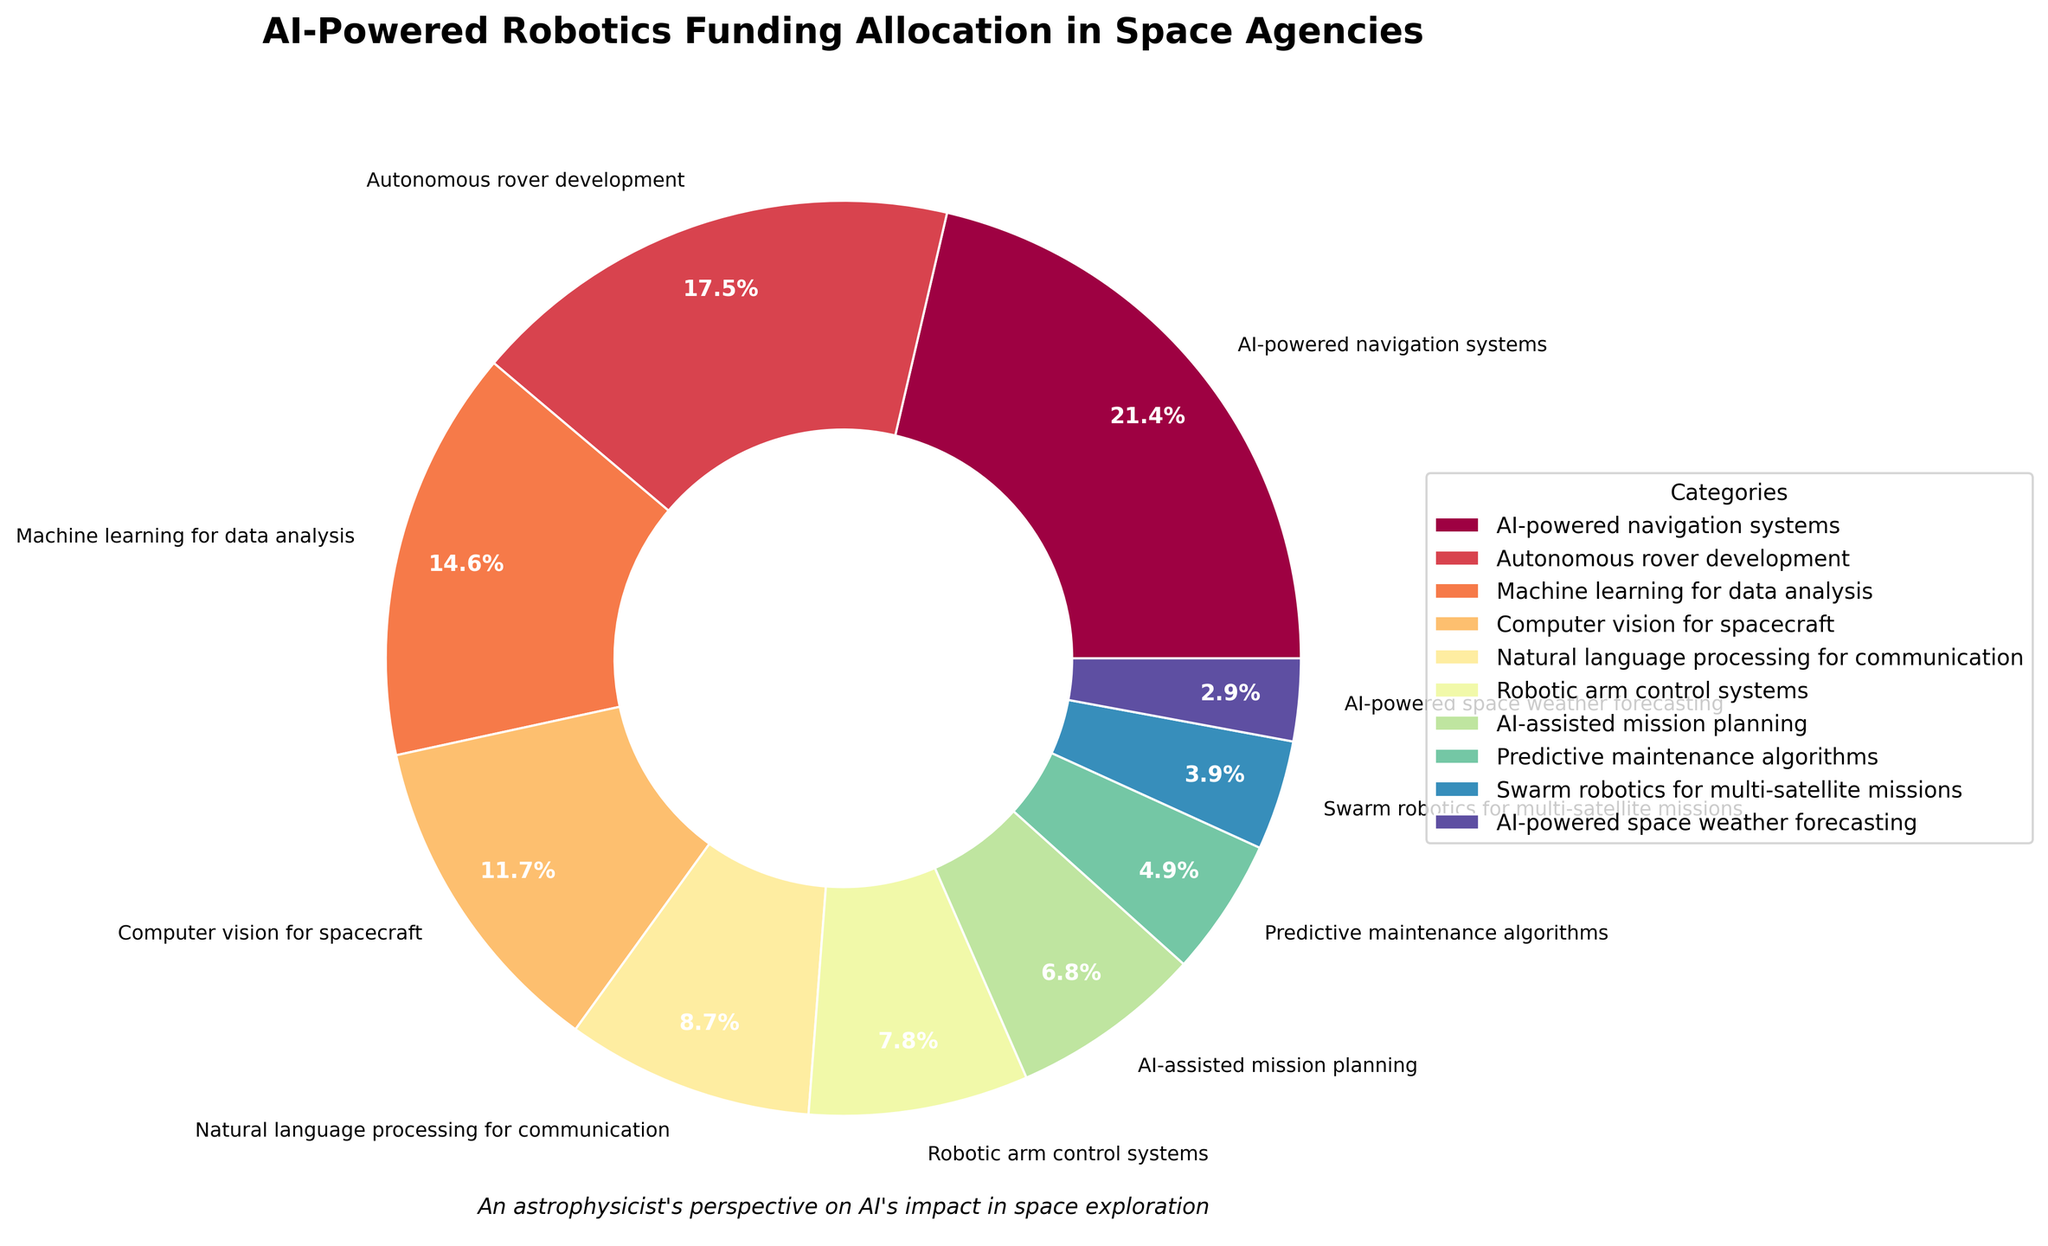How much funding is allocated to AI-powered navigation systems and autonomous rover development combined? To find the combined funding allocation for AI-powered navigation systems and autonomous rover development, add their percentages: 22% (AI-powered navigation systems) + 18% (autonomous rover development) = 40%.
Answer: 40% Which category gets more funding, machine learning for data analysis or computer vision for spacecraft? Compare the percentages: machine learning for data analysis (15%) and computer vision for spacecraft (12%). Since 15% is greater than 12%, machine learning for data analysis gets more funding.
Answer: Machine learning for data analysis What is the total funding allocated to categories related to data analysis and communication, specifically machine learning for data analysis and natural language processing for communication? Add the respective percentages: 15% (machine learning for data analysis) + 9% (natural language processing for communication) = 24%.
Answer: 24% Is the funding for AI-powered navigation systems greater than the combined funding for robotic arm control systems and predictive maintenance algorithms? Compare the percentage of AI-powered navigation systems (22%) with the sum of robotic arm control systems (8%) and predictive maintenance algorithms (5%): 8% + 5% = 13%. Since 22% is greater than 13%, the funding for AI-powered navigation systems is greater.
Answer: Yes Which category receives the least funding and how much is it? The category with the lowest percentage is AI-powered space weather forecasting with 3%.
Answer: AI-powered space weather forecasting, 3% How does the funding for swarm robotics for multi-satellite missions compare to the funding for AI-powered space weather forecasting? Compare their percentages: swarm robotics for multi-satellite missions is 4%, and AI-powered space weather forecasting is 3%. Since 4% is greater than 3%, swarm robotics receives more funding.
Answer: Swarm robotics for multi-satellite missions What is the percentage difference between the highest and lowest-funded categories? Subtract the percentage of the lowest-funded category (AI-powered space weather forecasting at 3%) from the highest-funded category (AI-powered navigation systems at 22%): 22% - 3% = 19%.
Answer: 19% Which categories, if any, receive exactly a single-digit percentage of funding? Identify categories with single-digit percentages: natural language processing for communication (9%), robotic arm control systems (8%), AI-assisted mission planning (7%), predictive maintenance algorithms (5%), and swarm robotics for multi-satellite missions (4%), AI-powered space weather forecasting (3%).
Answer: Natural language processing for communication, robotic arm control systems, AI-assisted mission planning, predictive maintenance algorithms, swarm robotics for multi-satellite missions, AI-powered space weather forecasting 